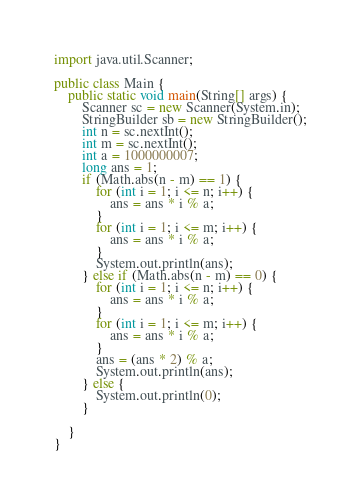<code> <loc_0><loc_0><loc_500><loc_500><_Java_>import java.util.Scanner;

public class Main {
	public static void main(String[] args) {
		Scanner sc = new Scanner(System.in);
		StringBuilder sb = new StringBuilder();
		int n = sc.nextInt();
		int m = sc.nextInt();
		int a = 1000000007;
		long ans = 1;
		if (Math.abs(n - m) == 1) {
			for (int i = 1; i <= n; i++) {
				ans = ans * i % a;
			}
			for (int i = 1; i <= m; i++) {
				ans = ans * i % a;
			}
			System.out.println(ans);
		} else if (Math.abs(n - m) == 0) {
			for (int i = 1; i <= n; i++) {
				ans = ans * i % a;
			}
			for (int i = 1; i <= m; i++) {
				ans = ans * i % a;
			}
			ans = (ans * 2) % a;
			System.out.println(ans);
		} else {
			System.out.println(0);
		}

	}
}
</code> 